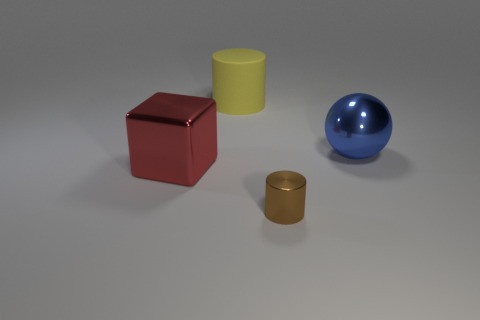Subtract all brown cylinders. Subtract all purple spheres. How many cylinders are left? 1 Add 4 big cyan cylinders. How many objects exist? 8 Subtract all cubes. How many objects are left? 3 Add 4 large balls. How many large balls exist? 5 Subtract 1 red cubes. How many objects are left? 3 Subtract all big blue balls. Subtract all blue metal objects. How many objects are left? 2 Add 2 large matte cylinders. How many large matte cylinders are left? 3 